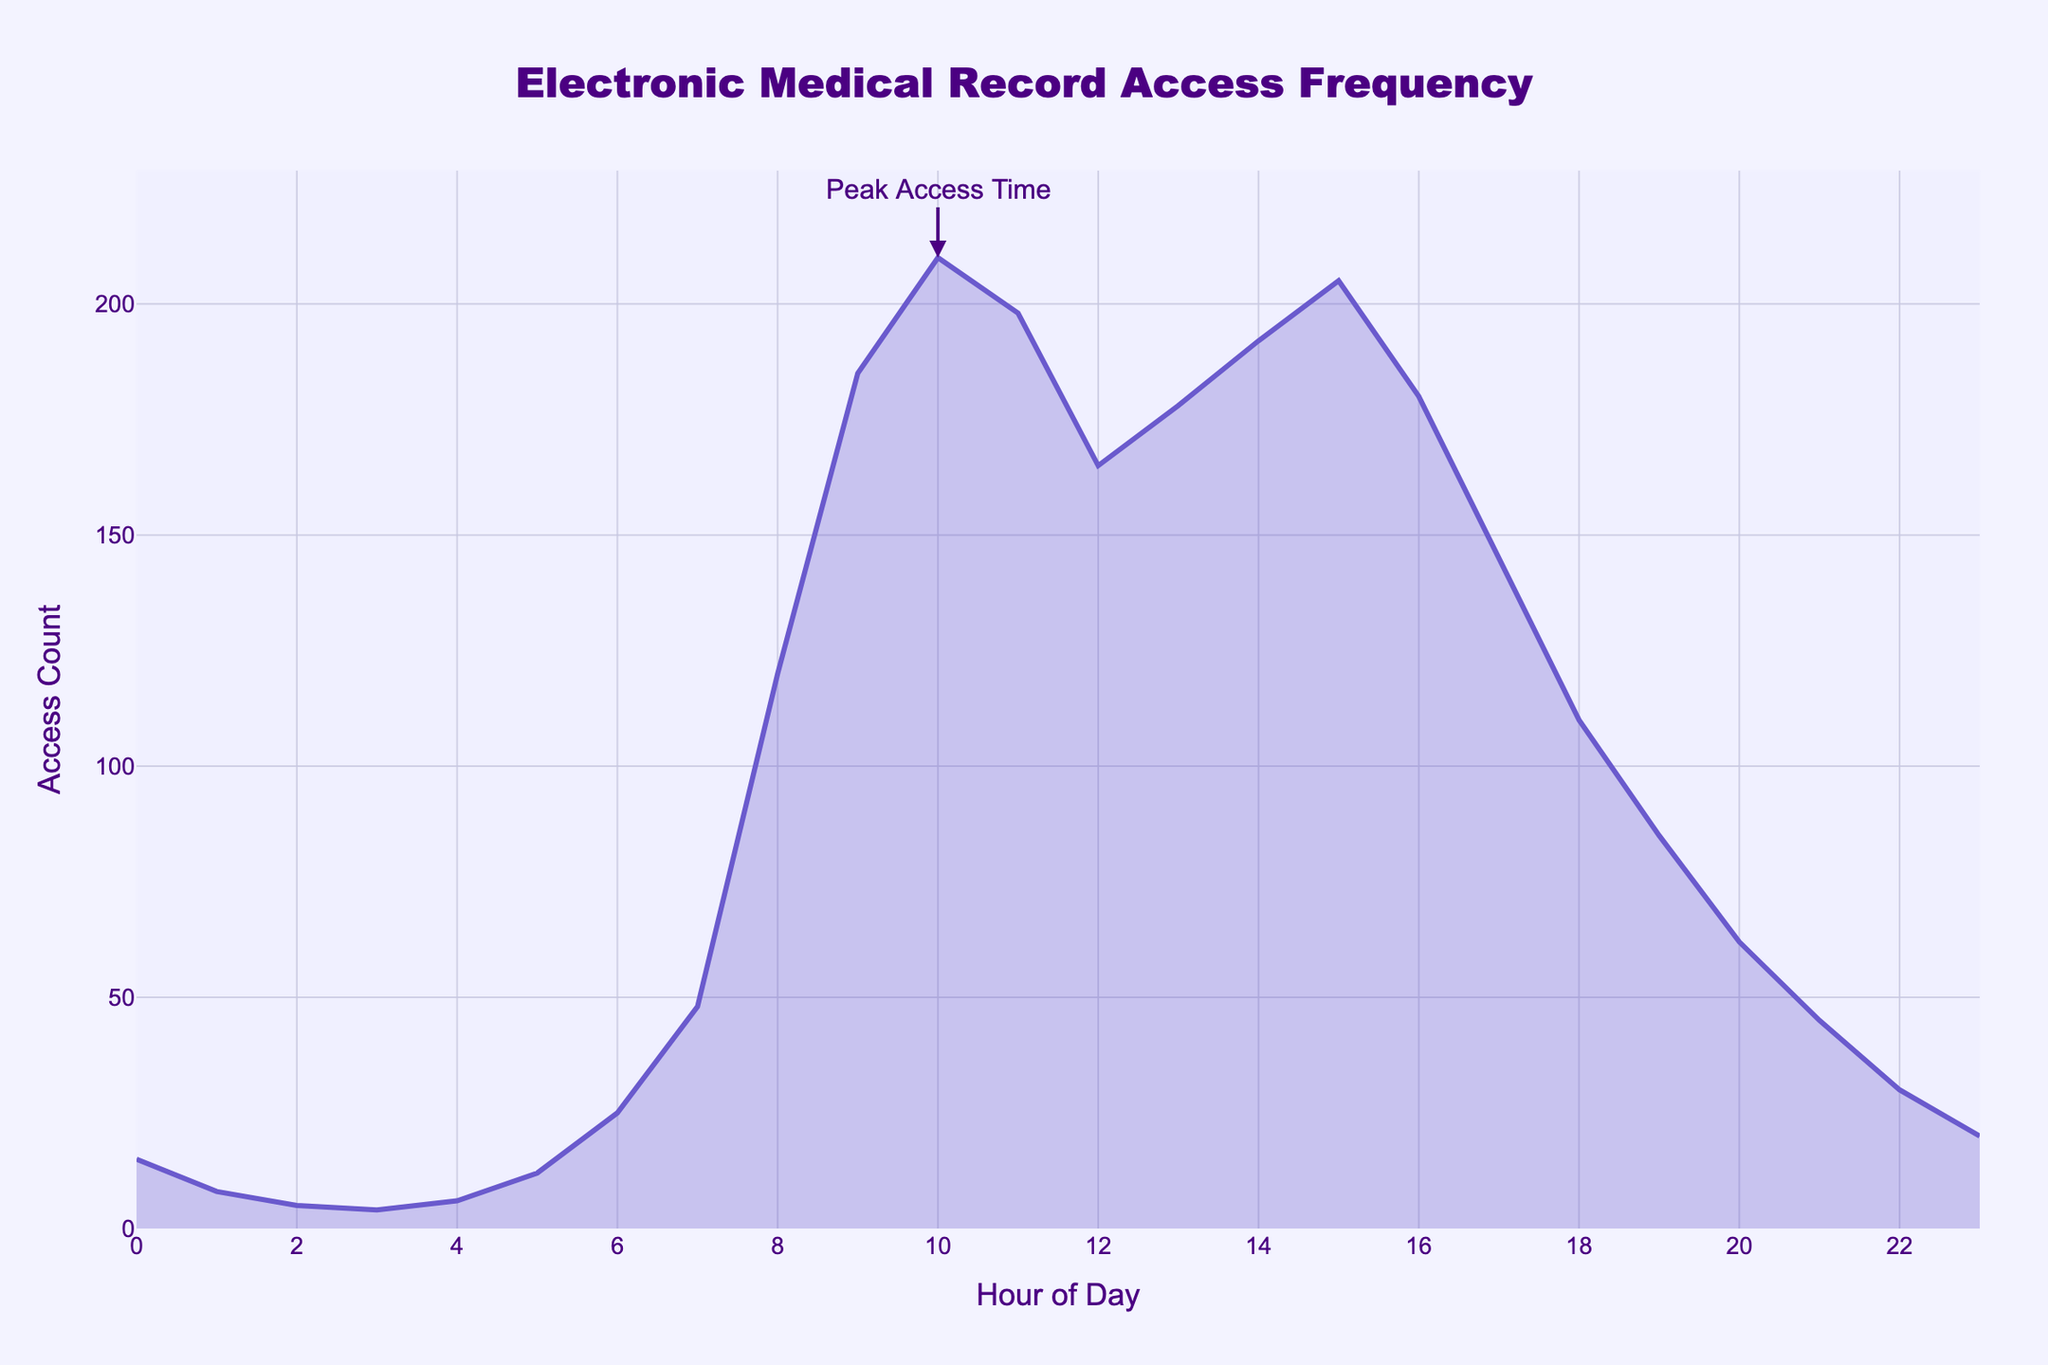What is the title of the plot? The title can be observed directly at the top of the figure and it's usually bold and larger.
Answer: Electronic Medical Record Access Frequency At what hour does access frequency peak? To answer this, one must find the highest point on the y-axis and locate the corresponding x-axis value. The annotation helps identify this peak.
Answer: 10 How many times is the electronic medical record accessed at 3 AM? Trace the point where the hour is 3 on the x-axis and note the corresponding value on the y-axis.
Answer: 4 How does the access frequency at 7 AM compare to 8 PM? Find the y-values for 7 AM and 8 PM on the x-axis and compare them.
Answer: Higher at 7 AM What is the access count difference between 9 AM and 5 PM? Identify the y-values for both 9 AM and 5 PM, then subtract the smaller value from the larger to find the difference.
Answer: 25 (210 at 10AM - 185 at 9AM) During what hours is the access count between 50 and 100? Locate the intervals on the plot where the access count (y-axis) falls between 50 and 100, and then note the corresponding x-axis values.
Answer: 6-7 AM and 7-8 PM How does the access frequency change from 6 AM to 10 AM? Examine the trend on the plot between these hours. Check if it increases, decreases, or remains steady.
Answer: Increases Which hour has the lowest access count? This involves identifying the lowest point on the y-axis and noting the corresponding x-axis value.
Answer: 3 What is the overall trend of access frequency throughout the day? Assess the general shape and movement of the plot line from left (midnight) to right (midnight).
Answer: Peaks mid-morning, gradually decreases How does the frequency of access at midnight compare with noon? Compare the access counts (y-axis values) at 12 AM and 12 PM.
Answer: Higher at noon 